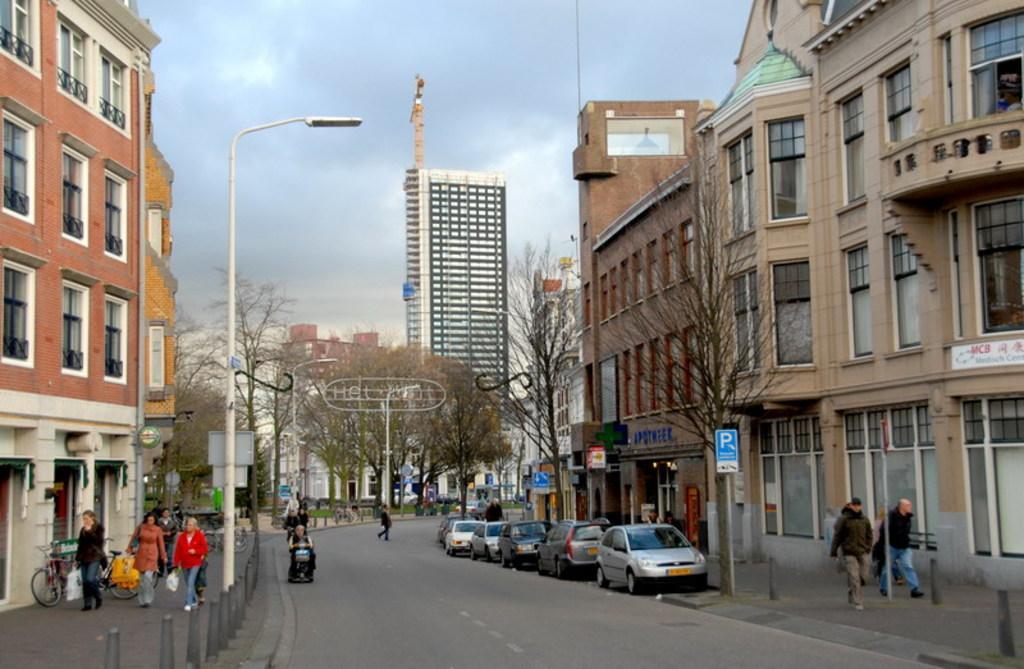Please provide a concise description of this image. This is the outside view of a city. Here we can see some buildings. And some people are walking on the side ways. Here some vehicles are parked on the side of the road. And this is the road here one person is riding his bike. On the background we can see some trees and this is the sky. 